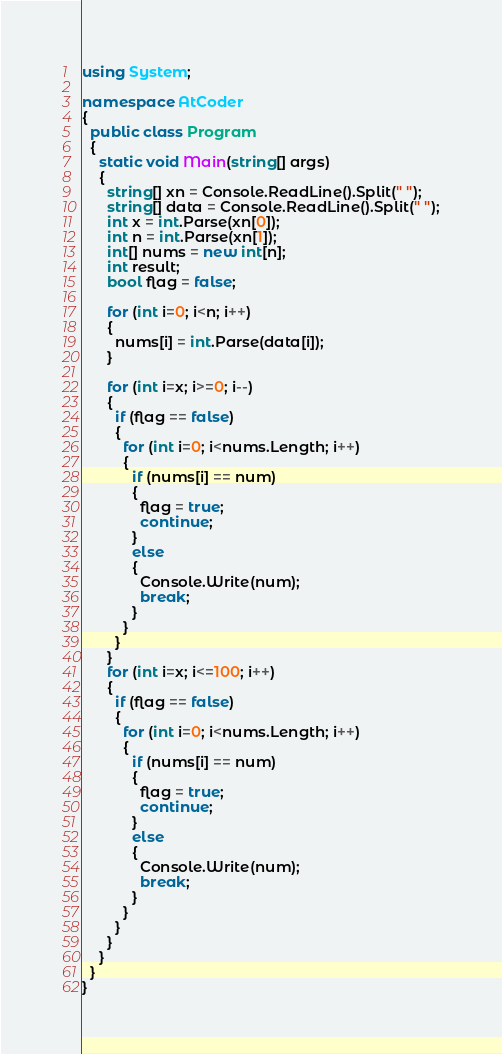<code> <loc_0><loc_0><loc_500><loc_500><_C#_>using System;

namespace AtCoder
{
  public class Program
  {
    static void Main(string[] args)
    {
      string[] xn = Console.ReadLine().Split(" ");
      string[] data = Console.ReadLine().Split(" ");
      int x = int.Parse(xn[0]);
      int n = int.Parse(xn[1]);
      int[] nums = new int[n];
      int result;
      bool flag = false;

      for (int i=0; i<n; i++)
      {
        nums[i] = int.Parse(data[i]);
      }

      for (int i=x; i>=0; i--)
      {
        if (flag == false)
        {
          for (int i=0; i<nums.Length; i++)
          {
            if (nums[i] == num)
            {
              flag = true;
              continue;
            }
            else
            {
              Console.Write(num);
              break;
            }
          }
        }
      }
      for (int i=x; i<=100; i++)
      {
        if (flag == false)
        {
          for (int i=0; i<nums.Length; i++)
          {
            if (nums[i] == num)
            {
              flag = true;
              continue;
            }
            else
            {
              Console.Write(num);
              break;
            }
          }
        }
      }
    }
  }
}
</code> 